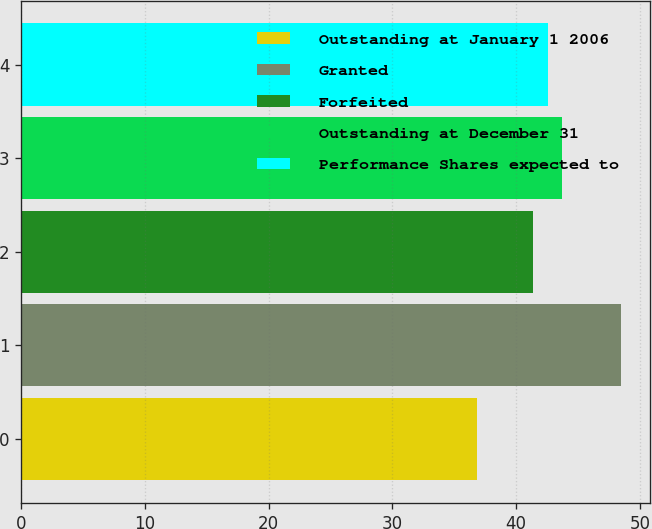Convert chart to OTSL. <chart><loc_0><loc_0><loc_500><loc_500><bar_chart><fcel>Outstanding at January 1 2006<fcel>Granted<fcel>Forfeited<fcel>Outstanding at December 31<fcel>Performance Shares expected to<nl><fcel>36.87<fcel>48.43<fcel>41.37<fcel>43.69<fcel>42.53<nl></chart> 